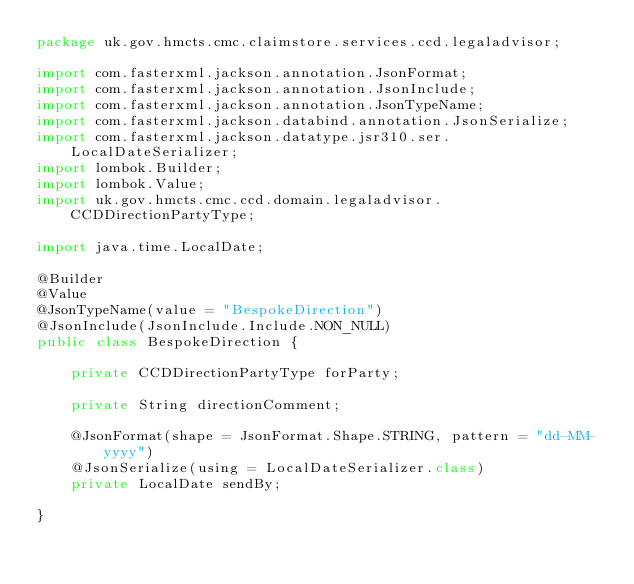Convert code to text. <code><loc_0><loc_0><loc_500><loc_500><_Java_>package uk.gov.hmcts.cmc.claimstore.services.ccd.legaladvisor;

import com.fasterxml.jackson.annotation.JsonFormat;
import com.fasterxml.jackson.annotation.JsonInclude;
import com.fasterxml.jackson.annotation.JsonTypeName;
import com.fasterxml.jackson.databind.annotation.JsonSerialize;
import com.fasterxml.jackson.datatype.jsr310.ser.LocalDateSerializer;
import lombok.Builder;
import lombok.Value;
import uk.gov.hmcts.cmc.ccd.domain.legaladvisor.CCDDirectionPartyType;

import java.time.LocalDate;

@Builder
@Value
@JsonTypeName(value = "BespokeDirection")
@JsonInclude(JsonInclude.Include.NON_NULL)
public class BespokeDirection {

    private CCDDirectionPartyType forParty;

    private String directionComment;

    @JsonFormat(shape = JsonFormat.Shape.STRING, pattern = "dd-MM-yyyy")
    @JsonSerialize(using = LocalDateSerializer.class)
    private LocalDate sendBy;

}
</code> 